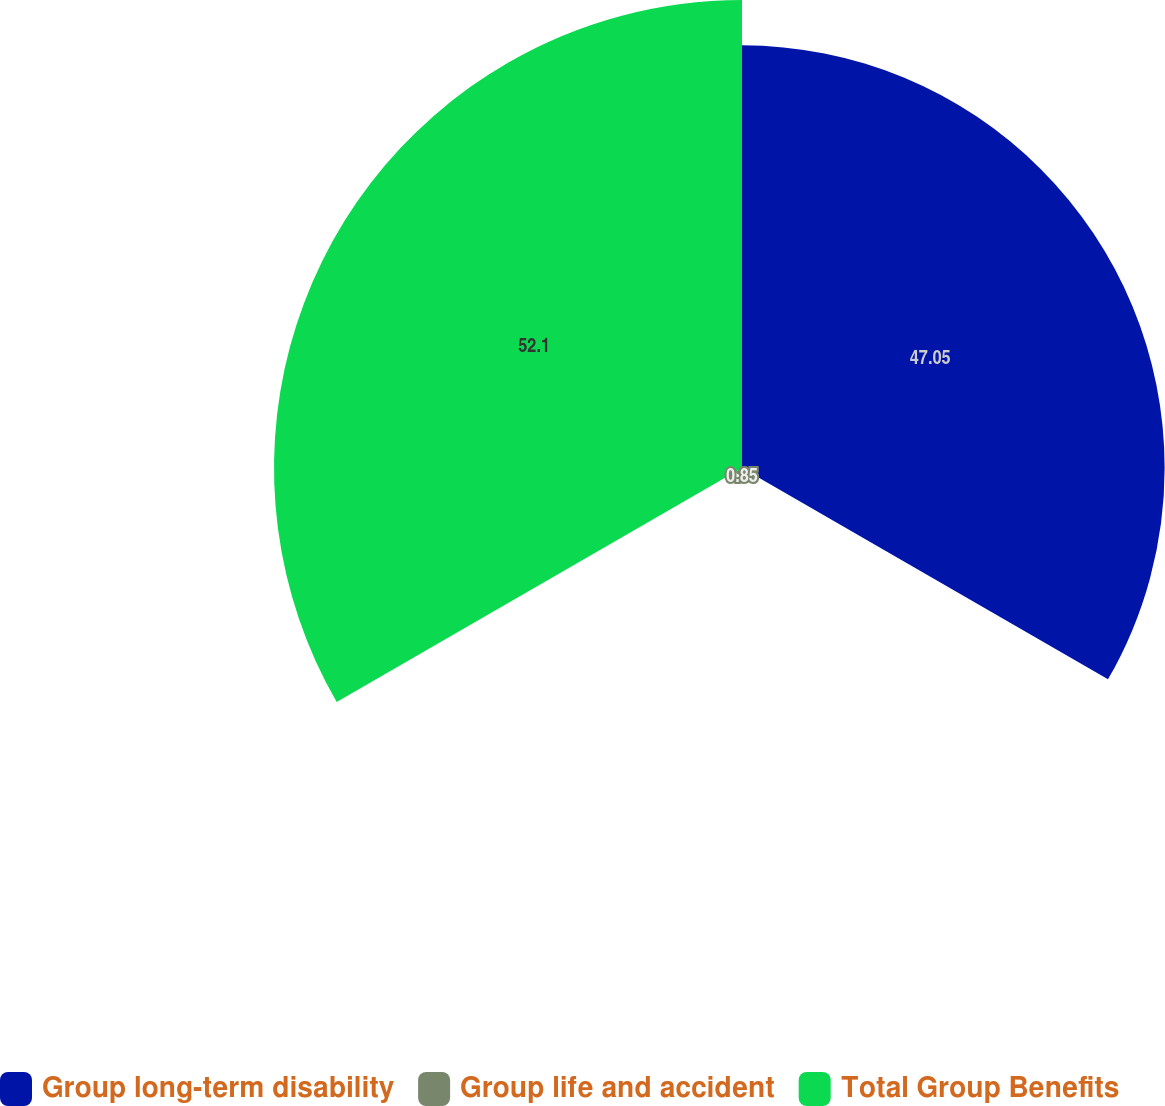<chart> <loc_0><loc_0><loc_500><loc_500><pie_chart><fcel>Group long-term disability<fcel>Group life and accident<fcel>Total Group Benefits<nl><fcel>47.05%<fcel>0.85%<fcel>52.1%<nl></chart> 